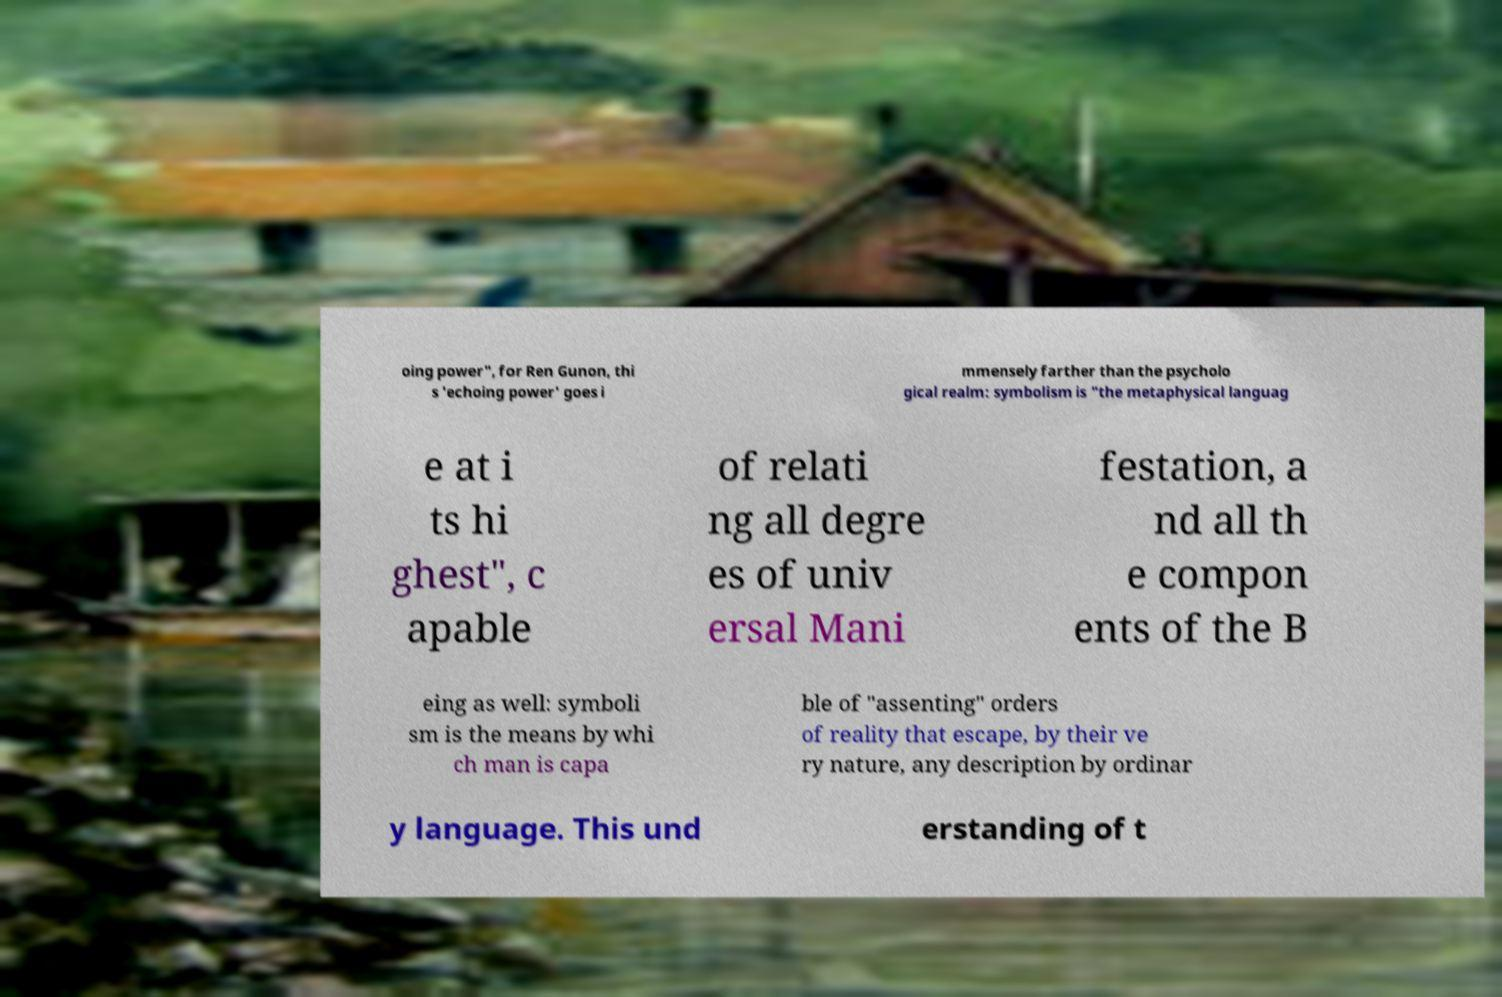Please read and relay the text visible in this image. What does it say? oing power", for Ren Gunon, thi s 'echoing power' goes i mmensely farther than the psycholo gical realm: symbolism is "the metaphysical languag e at i ts hi ghest", c apable of relati ng all degre es of univ ersal Mani festation, a nd all th e compon ents of the B eing as well: symboli sm is the means by whi ch man is capa ble of "assenting" orders of reality that escape, by their ve ry nature, any description by ordinar y language. This und erstanding of t 